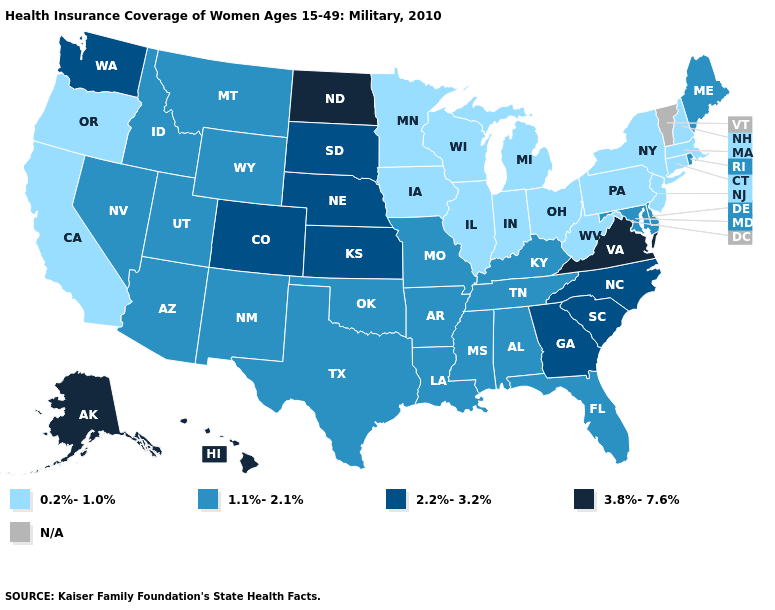Which states hav the highest value in the West?
Quick response, please. Alaska, Hawaii. Does West Virginia have the lowest value in the South?
Short answer required. Yes. What is the value of Minnesota?
Write a very short answer. 0.2%-1.0%. Among the states that border New Hampshire , does Massachusetts have the lowest value?
Concise answer only. Yes. What is the value of Delaware?
Write a very short answer. 1.1%-2.1%. What is the lowest value in the USA?
Short answer required. 0.2%-1.0%. Name the states that have a value in the range 1.1%-2.1%?
Concise answer only. Alabama, Arizona, Arkansas, Delaware, Florida, Idaho, Kentucky, Louisiana, Maine, Maryland, Mississippi, Missouri, Montana, Nevada, New Mexico, Oklahoma, Rhode Island, Tennessee, Texas, Utah, Wyoming. Name the states that have a value in the range N/A?
Write a very short answer. Vermont. Which states have the highest value in the USA?
Give a very brief answer. Alaska, Hawaii, North Dakota, Virginia. What is the value of Arizona?
Keep it brief. 1.1%-2.1%. Which states have the lowest value in the South?
Quick response, please. West Virginia. What is the value of Michigan?
Quick response, please. 0.2%-1.0%. Is the legend a continuous bar?
Write a very short answer. No. Name the states that have a value in the range 1.1%-2.1%?
Quick response, please. Alabama, Arizona, Arkansas, Delaware, Florida, Idaho, Kentucky, Louisiana, Maine, Maryland, Mississippi, Missouri, Montana, Nevada, New Mexico, Oklahoma, Rhode Island, Tennessee, Texas, Utah, Wyoming. 